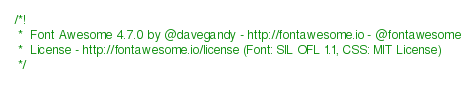Convert code to text. <code><loc_0><loc_0><loc_500><loc_500><_CSS_>/*!
 *  Font Awesome 4.7.0 by @davegandy - http://fontawesome.io - @fontawesome
 *  License - http://fontawesome.io/license (Font: SIL OFL 1.1, CSS: MIT License)
 */
  </code> 